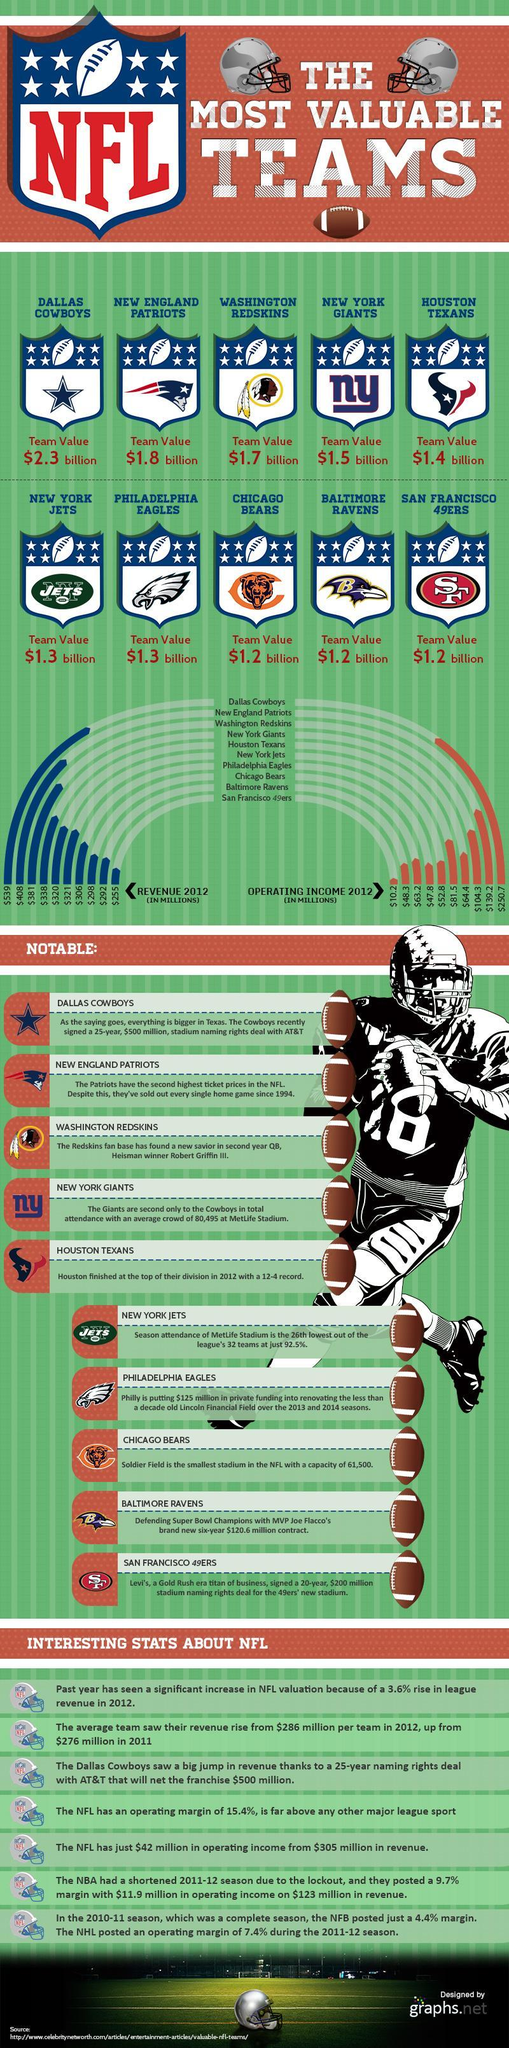How much revenue (in millions) do the New York Giants generate in 2012?
Answer the question with a short phrase. $338 What is the value of the Houston Texans football team? $1.4 billion How much revenue (in millions) do the Dallas Cowboys generate in 2012? $539 Which NFL team generated the highest revenue in 2012? DALLAS COWBOYS What is the value of the Washington Redskins football team? $1.7 billion What is the operating income (in millions) of the New England Patriots in 2012? $139.2 What is the operating income (in millions) of the Chicago Bears in 2012? $63.2 How much revenue (in millions) do the New York Jets generate in 2012? $321 Which NFL team generated the least revenue in 2012? San Francisco 49ers Which NFL team has the highest value franchise? DALLAS COWBOYS 